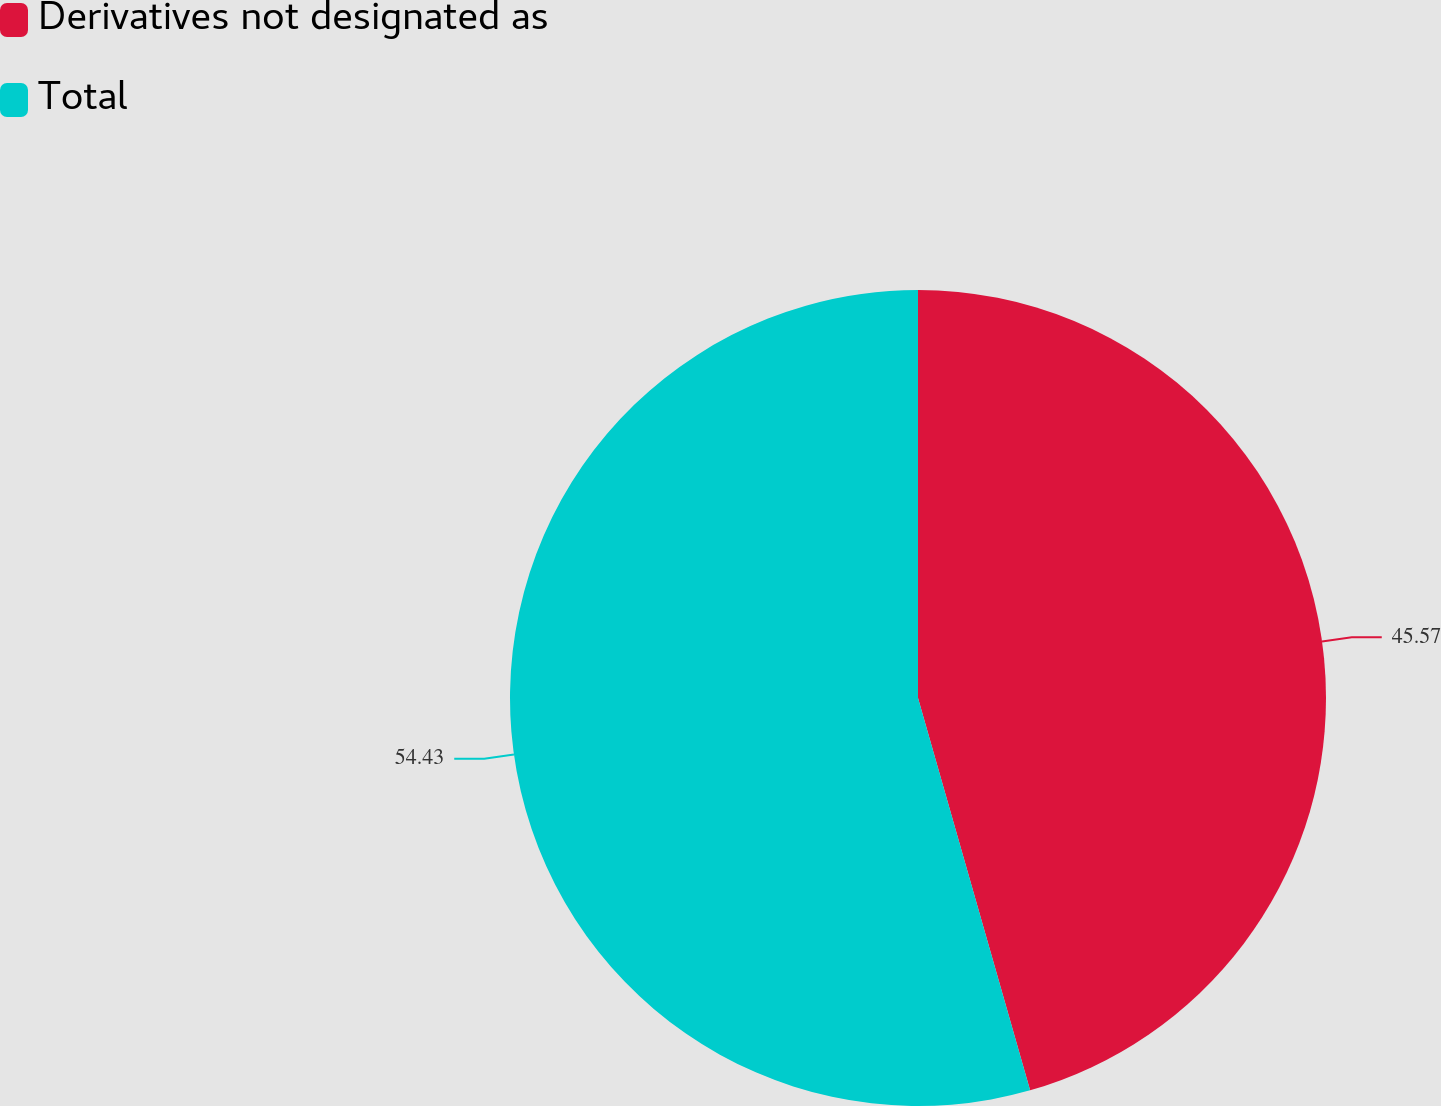<chart> <loc_0><loc_0><loc_500><loc_500><pie_chart><fcel>Derivatives not designated as<fcel>Total<nl><fcel>45.57%<fcel>54.43%<nl></chart> 